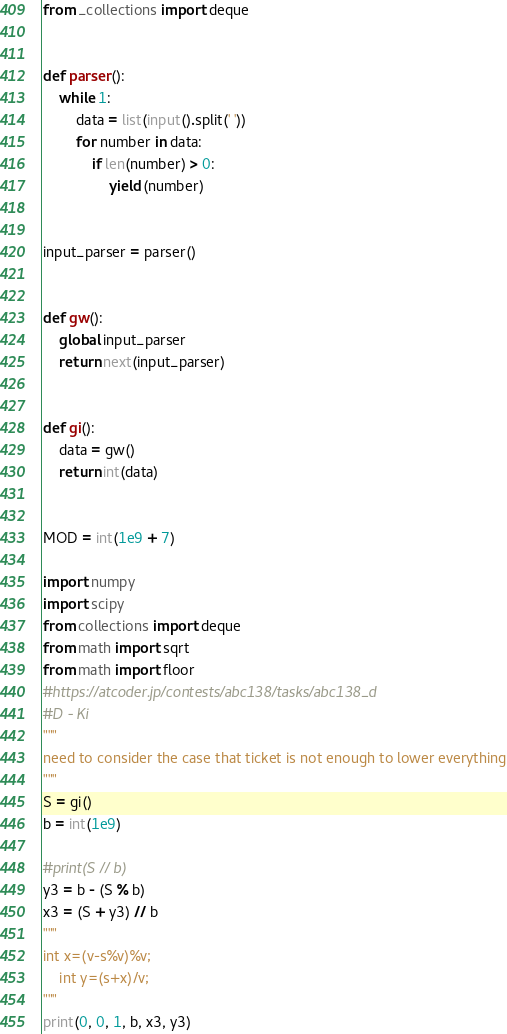<code> <loc_0><loc_0><loc_500><loc_500><_Python_>from _collections import deque


def parser():
    while 1:
        data = list(input().split(' '))
        for number in data:
            if len(number) > 0:
                yield (number)


input_parser = parser()


def gw():
    global input_parser
    return next(input_parser)


def gi():
    data = gw()
    return int(data)


MOD = int(1e9 + 7)

import numpy
import scipy
from collections import deque
from math import sqrt
from math import floor
#https://atcoder.jp/contests/abc138/tasks/abc138_d
#D - Ki
"""
need to consider the case that ticket is not enough to lower everything
"""
S = gi()
b = int(1e9)

#print(S // b)
y3 = b - (S % b)
x3 = (S + y3) // b
"""
int x=(v-s%v)%v;
    int y=(s+x)/v;
"""
print(0, 0, 1, b, x3, y3)
</code> 